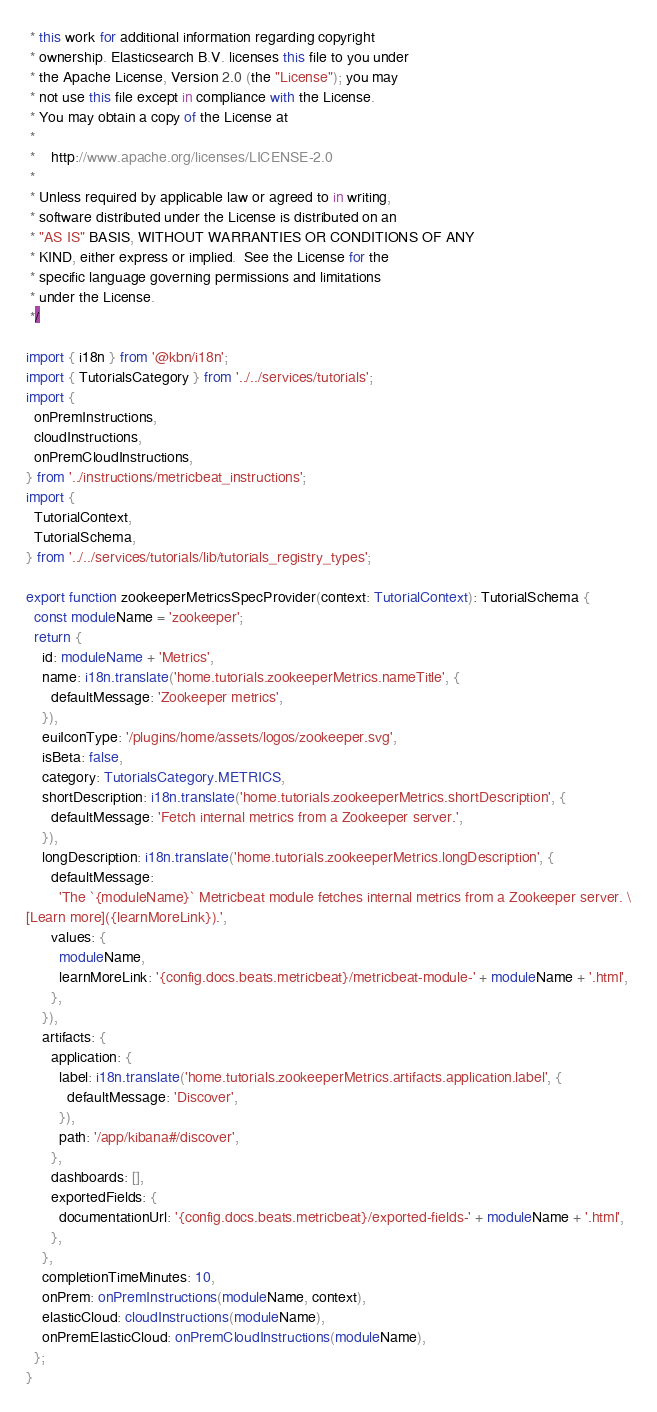<code> <loc_0><loc_0><loc_500><loc_500><_TypeScript_> * this work for additional information regarding copyright
 * ownership. Elasticsearch B.V. licenses this file to you under
 * the Apache License, Version 2.0 (the "License"); you may
 * not use this file except in compliance with the License.
 * You may obtain a copy of the License at
 *
 *    http://www.apache.org/licenses/LICENSE-2.0
 *
 * Unless required by applicable law or agreed to in writing,
 * software distributed under the License is distributed on an
 * "AS IS" BASIS, WITHOUT WARRANTIES OR CONDITIONS OF ANY
 * KIND, either express or implied.  See the License for the
 * specific language governing permissions and limitations
 * under the License.
 */

import { i18n } from '@kbn/i18n';
import { TutorialsCategory } from '../../services/tutorials';
import {
  onPremInstructions,
  cloudInstructions,
  onPremCloudInstructions,
} from '../instructions/metricbeat_instructions';
import {
  TutorialContext,
  TutorialSchema,
} from '../../services/tutorials/lib/tutorials_registry_types';

export function zookeeperMetricsSpecProvider(context: TutorialContext): TutorialSchema {
  const moduleName = 'zookeeper';
  return {
    id: moduleName + 'Metrics',
    name: i18n.translate('home.tutorials.zookeeperMetrics.nameTitle', {
      defaultMessage: 'Zookeeper metrics',
    }),
    euiIconType: '/plugins/home/assets/logos/zookeeper.svg',
    isBeta: false,
    category: TutorialsCategory.METRICS,
    shortDescription: i18n.translate('home.tutorials.zookeeperMetrics.shortDescription', {
      defaultMessage: 'Fetch internal metrics from a Zookeeper server.',
    }),
    longDescription: i18n.translate('home.tutorials.zookeeperMetrics.longDescription', {
      defaultMessage:
        'The `{moduleName}` Metricbeat module fetches internal metrics from a Zookeeper server. \
[Learn more]({learnMoreLink}).',
      values: {
        moduleName,
        learnMoreLink: '{config.docs.beats.metricbeat}/metricbeat-module-' + moduleName + '.html',
      },
    }),
    artifacts: {
      application: {
        label: i18n.translate('home.tutorials.zookeeperMetrics.artifacts.application.label', {
          defaultMessage: 'Discover',
        }),
        path: '/app/kibana#/discover',
      },
      dashboards: [],
      exportedFields: {
        documentationUrl: '{config.docs.beats.metricbeat}/exported-fields-' + moduleName + '.html',
      },
    },
    completionTimeMinutes: 10,
    onPrem: onPremInstructions(moduleName, context),
    elasticCloud: cloudInstructions(moduleName),
    onPremElasticCloud: onPremCloudInstructions(moduleName),
  };
}
</code> 